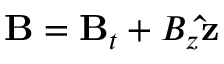Convert formula to latex. <formula><loc_0><loc_0><loc_500><loc_500>B = B _ { t } + B _ { z } \hat { z }</formula> 